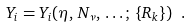Convert formula to latex. <formula><loc_0><loc_0><loc_500><loc_500>Y _ { i } = Y _ { i } ( \eta , \, N _ { \nu } , \, \dots ; \, \{ R _ { k } \} ) \ .</formula> 